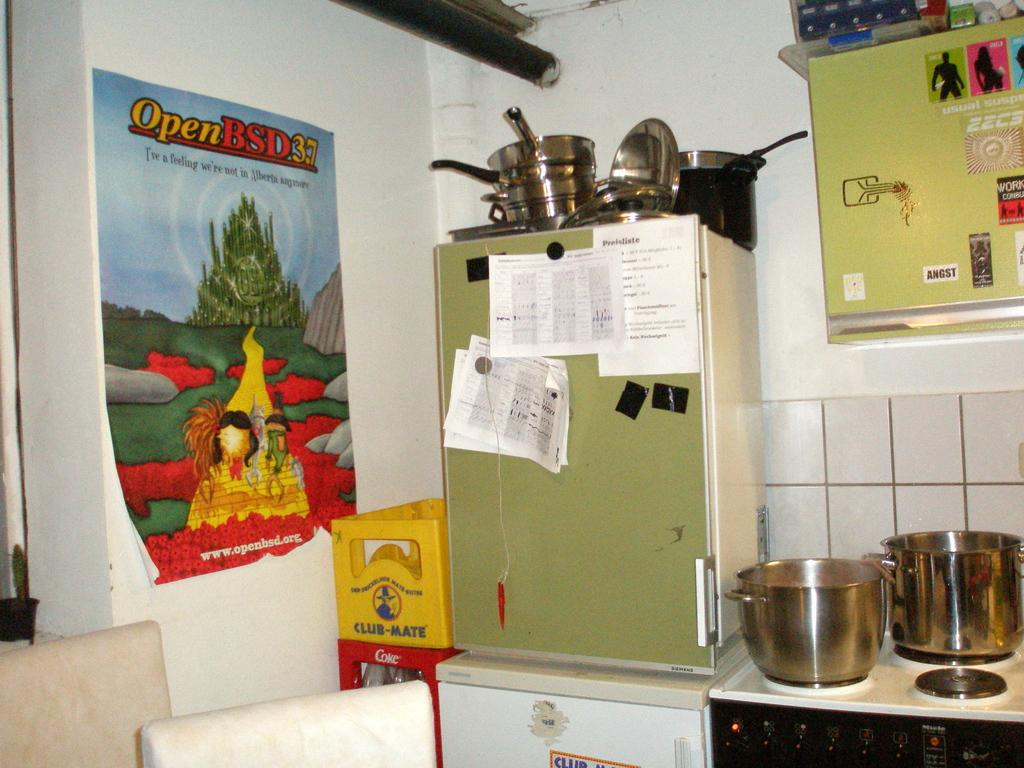<image>
Present a compact description of the photo's key features. An OpenBSD37 poster on the left wall of a kitchen area. 